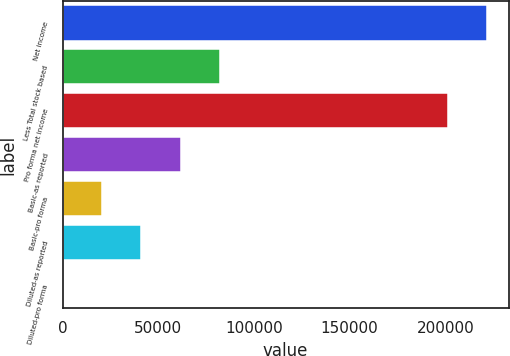<chart> <loc_0><loc_0><loc_500><loc_500><bar_chart><fcel>Net income<fcel>Less Total stock based<fcel>Pro forma net income<fcel>Basic-as reported<fcel>Basic-pro forma<fcel>Diluted-as reported<fcel>Diluted-pro forma<nl><fcel>222037<fcel>82536.3<fcel>201403<fcel>61902.5<fcel>20634.9<fcel>41268.7<fcel>1.11<nl></chart> 